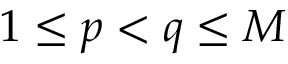Convert formula to latex. <formula><loc_0><loc_0><loc_500><loc_500>1 \leq p < q \leq M</formula> 